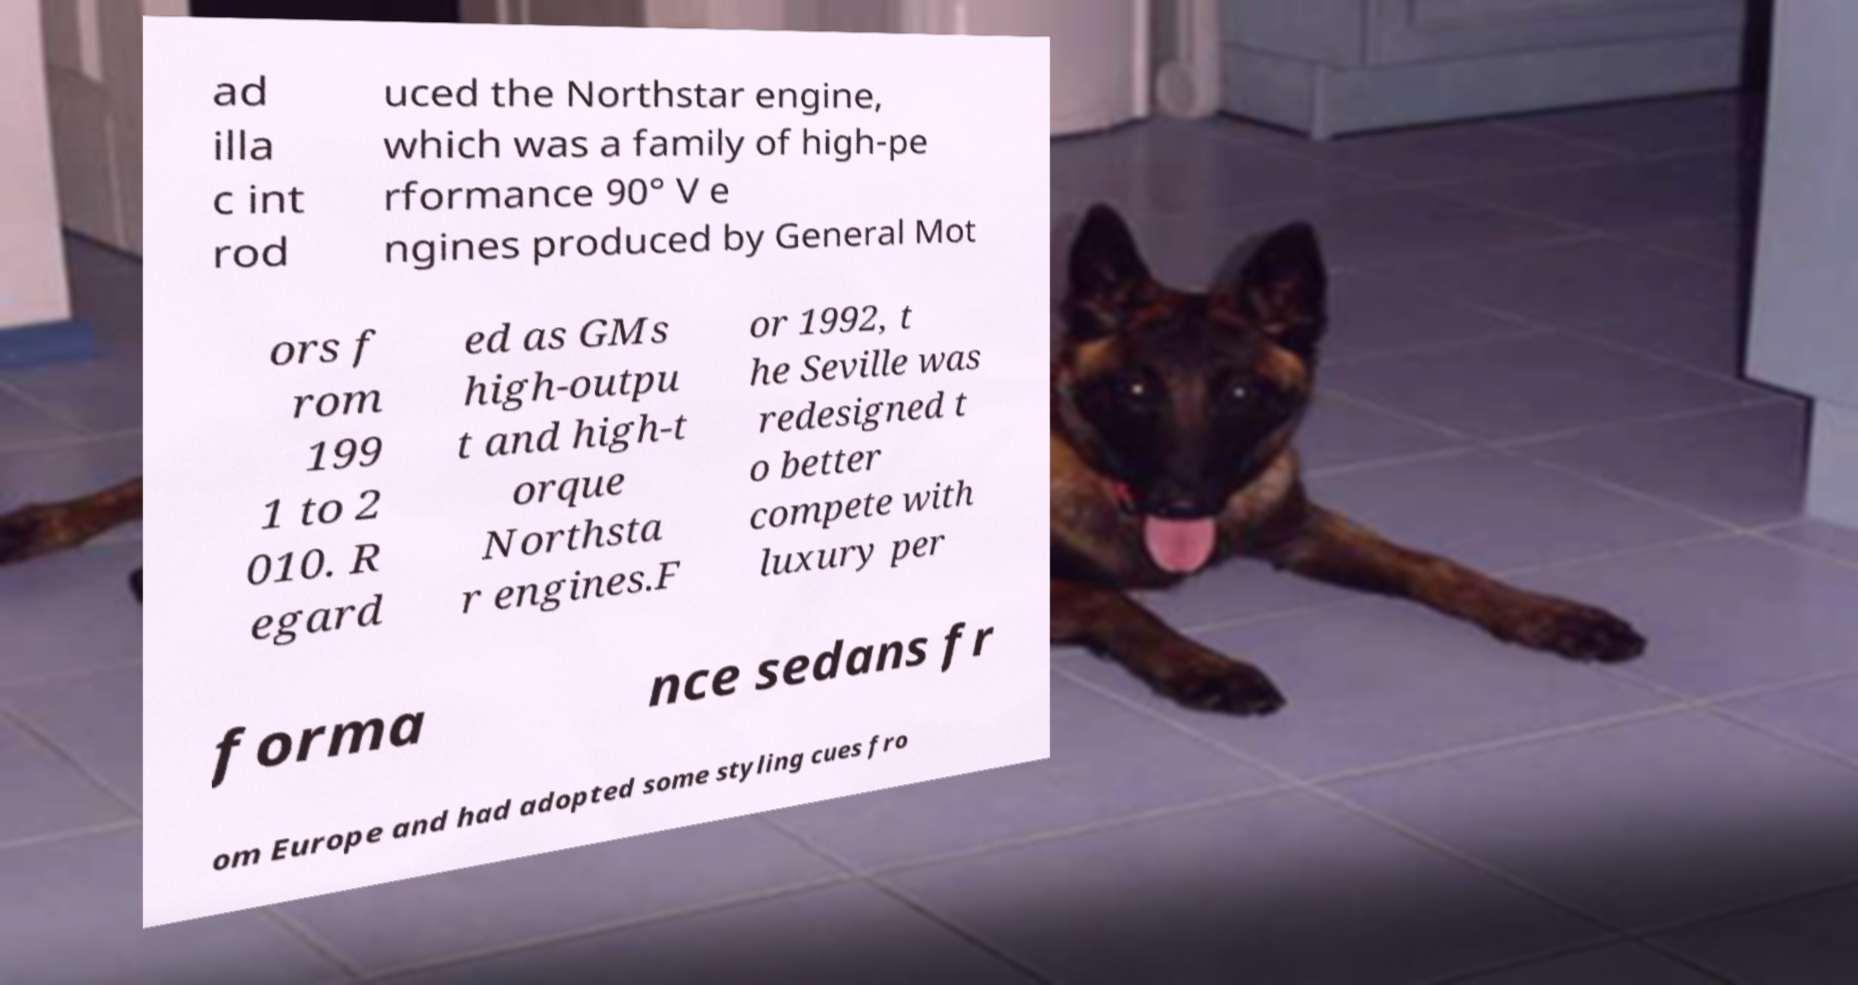There's text embedded in this image that I need extracted. Can you transcribe it verbatim? ad illa c int rod uced the Northstar engine, which was a family of high-pe rformance 90° V e ngines produced by General Mot ors f rom 199 1 to 2 010. R egard ed as GMs high-outpu t and high-t orque Northsta r engines.F or 1992, t he Seville was redesigned t o better compete with luxury per forma nce sedans fr om Europe and had adopted some styling cues fro 